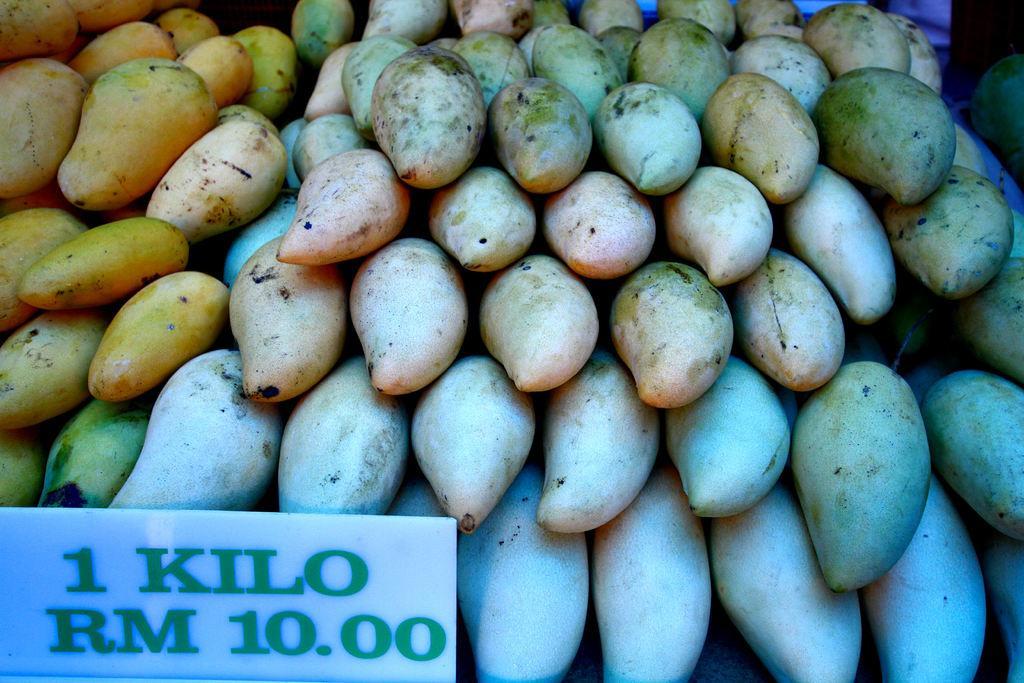In one or two sentences, can you explain what this image depicts? In this image we can see group of fruits placed one above another. At the bottom we can see a signboard with some text on it. 